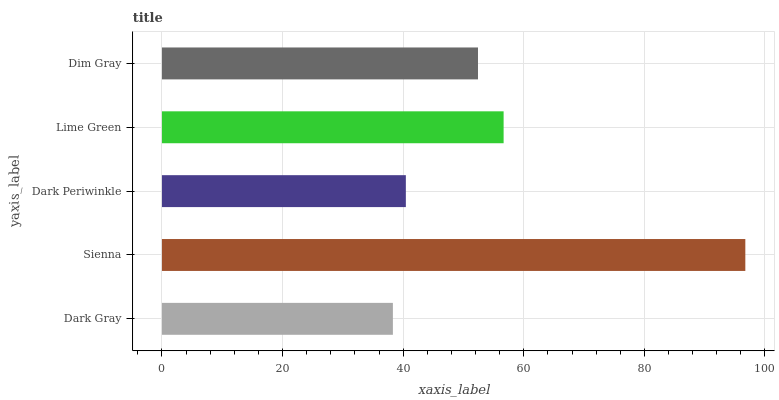Is Dark Gray the minimum?
Answer yes or no. Yes. Is Sienna the maximum?
Answer yes or no. Yes. Is Dark Periwinkle the minimum?
Answer yes or no. No. Is Dark Periwinkle the maximum?
Answer yes or no. No. Is Sienna greater than Dark Periwinkle?
Answer yes or no. Yes. Is Dark Periwinkle less than Sienna?
Answer yes or no. Yes. Is Dark Periwinkle greater than Sienna?
Answer yes or no. No. Is Sienna less than Dark Periwinkle?
Answer yes or no. No. Is Dim Gray the high median?
Answer yes or no. Yes. Is Dim Gray the low median?
Answer yes or no. Yes. Is Lime Green the high median?
Answer yes or no. No. Is Dark Gray the low median?
Answer yes or no. No. 